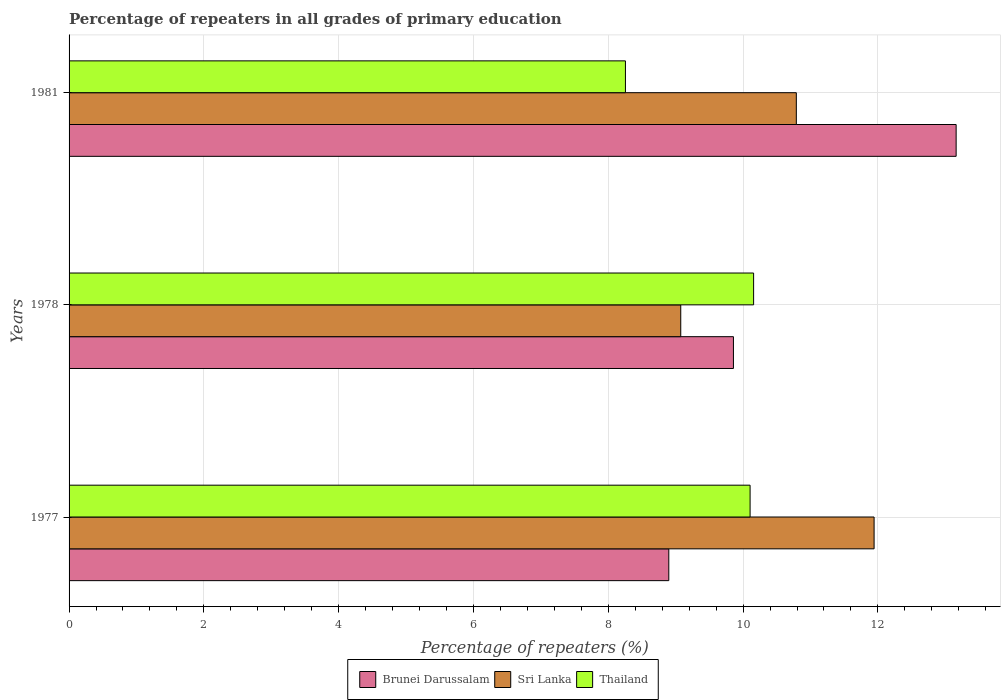How many groups of bars are there?
Offer a very short reply. 3. Are the number of bars on each tick of the Y-axis equal?
Give a very brief answer. Yes. How many bars are there on the 2nd tick from the bottom?
Ensure brevity in your answer.  3. What is the label of the 3rd group of bars from the top?
Ensure brevity in your answer.  1977. In how many cases, is the number of bars for a given year not equal to the number of legend labels?
Keep it short and to the point. 0. What is the percentage of repeaters in Sri Lanka in 1978?
Offer a very short reply. 9.08. Across all years, what is the maximum percentage of repeaters in Brunei Darussalam?
Make the answer very short. 13.16. Across all years, what is the minimum percentage of repeaters in Sri Lanka?
Your answer should be compact. 9.08. In which year was the percentage of repeaters in Brunei Darussalam maximum?
Provide a short and direct response. 1981. What is the total percentage of repeaters in Sri Lanka in the graph?
Ensure brevity in your answer.  31.81. What is the difference between the percentage of repeaters in Sri Lanka in 1977 and that in 1978?
Provide a short and direct response. 2.87. What is the difference between the percentage of repeaters in Sri Lanka in 1981 and the percentage of repeaters in Thailand in 1978?
Your response must be concise. 0.63. What is the average percentage of repeaters in Sri Lanka per year?
Make the answer very short. 10.6. In the year 1977, what is the difference between the percentage of repeaters in Thailand and percentage of repeaters in Sri Lanka?
Make the answer very short. -1.84. In how many years, is the percentage of repeaters in Sri Lanka greater than 10.8 %?
Your answer should be very brief. 1. What is the ratio of the percentage of repeaters in Sri Lanka in 1977 to that in 1978?
Your answer should be very brief. 1.32. Is the difference between the percentage of repeaters in Thailand in 1977 and 1978 greater than the difference between the percentage of repeaters in Sri Lanka in 1977 and 1978?
Provide a succinct answer. No. What is the difference between the highest and the second highest percentage of repeaters in Thailand?
Ensure brevity in your answer.  0.05. What is the difference between the highest and the lowest percentage of repeaters in Sri Lanka?
Offer a terse response. 2.87. In how many years, is the percentage of repeaters in Brunei Darussalam greater than the average percentage of repeaters in Brunei Darussalam taken over all years?
Your answer should be compact. 1. What does the 3rd bar from the top in 1981 represents?
Keep it short and to the point. Brunei Darussalam. What does the 3rd bar from the bottom in 1978 represents?
Offer a terse response. Thailand. Are all the bars in the graph horizontal?
Offer a very short reply. Yes. Does the graph contain any zero values?
Keep it short and to the point. No. Where does the legend appear in the graph?
Offer a very short reply. Bottom center. How many legend labels are there?
Ensure brevity in your answer.  3. What is the title of the graph?
Your answer should be very brief. Percentage of repeaters in all grades of primary education. What is the label or title of the X-axis?
Keep it short and to the point. Percentage of repeaters (%). What is the Percentage of repeaters (%) in Brunei Darussalam in 1977?
Your answer should be compact. 8.9. What is the Percentage of repeaters (%) of Sri Lanka in 1977?
Your response must be concise. 11.94. What is the Percentage of repeaters (%) of Thailand in 1977?
Your response must be concise. 10.1. What is the Percentage of repeaters (%) of Brunei Darussalam in 1978?
Your answer should be compact. 9.86. What is the Percentage of repeaters (%) of Sri Lanka in 1978?
Keep it short and to the point. 9.08. What is the Percentage of repeaters (%) of Thailand in 1978?
Offer a very short reply. 10.16. What is the Percentage of repeaters (%) in Brunei Darussalam in 1981?
Give a very brief answer. 13.16. What is the Percentage of repeaters (%) in Sri Lanka in 1981?
Give a very brief answer. 10.79. What is the Percentage of repeaters (%) of Thailand in 1981?
Offer a terse response. 8.25. Across all years, what is the maximum Percentage of repeaters (%) of Brunei Darussalam?
Your response must be concise. 13.16. Across all years, what is the maximum Percentage of repeaters (%) in Sri Lanka?
Provide a succinct answer. 11.94. Across all years, what is the maximum Percentage of repeaters (%) in Thailand?
Provide a succinct answer. 10.16. Across all years, what is the minimum Percentage of repeaters (%) of Brunei Darussalam?
Your answer should be compact. 8.9. Across all years, what is the minimum Percentage of repeaters (%) in Sri Lanka?
Offer a terse response. 9.08. Across all years, what is the minimum Percentage of repeaters (%) of Thailand?
Keep it short and to the point. 8.25. What is the total Percentage of repeaters (%) in Brunei Darussalam in the graph?
Your response must be concise. 31.92. What is the total Percentage of repeaters (%) in Sri Lanka in the graph?
Offer a very short reply. 31.81. What is the total Percentage of repeaters (%) of Thailand in the graph?
Give a very brief answer. 28.51. What is the difference between the Percentage of repeaters (%) in Brunei Darussalam in 1977 and that in 1978?
Offer a terse response. -0.96. What is the difference between the Percentage of repeaters (%) of Sri Lanka in 1977 and that in 1978?
Keep it short and to the point. 2.87. What is the difference between the Percentage of repeaters (%) of Thailand in 1977 and that in 1978?
Offer a terse response. -0.05. What is the difference between the Percentage of repeaters (%) of Brunei Darussalam in 1977 and that in 1981?
Keep it short and to the point. -4.26. What is the difference between the Percentage of repeaters (%) in Sri Lanka in 1977 and that in 1981?
Give a very brief answer. 1.15. What is the difference between the Percentage of repeaters (%) in Thailand in 1977 and that in 1981?
Offer a very short reply. 1.85. What is the difference between the Percentage of repeaters (%) of Brunei Darussalam in 1978 and that in 1981?
Provide a succinct answer. -3.3. What is the difference between the Percentage of repeaters (%) of Sri Lanka in 1978 and that in 1981?
Make the answer very short. -1.71. What is the difference between the Percentage of repeaters (%) in Thailand in 1978 and that in 1981?
Offer a terse response. 1.9. What is the difference between the Percentage of repeaters (%) of Brunei Darussalam in 1977 and the Percentage of repeaters (%) of Sri Lanka in 1978?
Your answer should be very brief. -0.18. What is the difference between the Percentage of repeaters (%) of Brunei Darussalam in 1977 and the Percentage of repeaters (%) of Thailand in 1978?
Your response must be concise. -1.26. What is the difference between the Percentage of repeaters (%) of Sri Lanka in 1977 and the Percentage of repeaters (%) of Thailand in 1978?
Your response must be concise. 1.79. What is the difference between the Percentage of repeaters (%) in Brunei Darussalam in 1977 and the Percentage of repeaters (%) in Sri Lanka in 1981?
Give a very brief answer. -1.89. What is the difference between the Percentage of repeaters (%) of Brunei Darussalam in 1977 and the Percentage of repeaters (%) of Thailand in 1981?
Offer a very short reply. 0.64. What is the difference between the Percentage of repeaters (%) in Sri Lanka in 1977 and the Percentage of repeaters (%) in Thailand in 1981?
Offer a terse response. 3.69. What is the difference between the Percentage of repeaters (%) in Brunei Darussalam in 1978 and the Percentage of repeaters (%) in Sri Lanka in 1981?
Make the answer very short. -0.93. What is the difference between the Percentage of repeaters (%) in Brunei Darussalam in 1978 and the Percentage of repeaters (%) in Thailand in 1981?
Give a very brief answer. 1.6. What is the difference between the Percentage of repeaters (%) of Sri Lanka in 1978 and the Percentage of repeaters (%) of Thailand in 1981?
Provide a succinct answer. 0.82. What is the average Percentage of repeaters (%) of Brunei Darussalam per year?
Make the answer very short. 10.64. What is the average Percentage of repeaters (%) of Sri Lanka per year?
Your answer should be very brief. 10.6. What is the average Percentage of repeaters (%) in Thailand per year?
Offer a terse response. 9.5. In the year 1977, what is the difference between the Percentage of repeaters (%) in Brunei Darussalam and Percentage of repeaters (%) in Sri Lanka?
Provide a succinct answer. -3.05. In the year 1977, what is the difference between the Percentage of repeaters (%) in Brunei Darussalam and Percentage of repeaters (%) in Thailand?
Your response must be concise. -1.21. In the year 1977, what is the difference between the Percentage of repeaters (%) in Sri Lanka and Percentage of repeaters (%) in Thailand?
Your answer should be compact. 1.84. In the year 1978, what is the difference between the Percentage of repeaters (%) in Brunei Darussalam and Percentage of repeaters (%) in Sri Lanka?
Offer a terse response. 0.78. In the year 1978, what is the difference between the Percentage of repeaters (%) of Brunei Darussalam and Percentage of repeaters (%) of Thailand?
Give a very brief answer. -0.3. In the year 1978, what is the difference between the Percentage of repeaters (%) of Sri Lanka and Percentage of repeaters (%) of Thailand?
Provide a short and direct response. -1.08. In the year 1981, what is the difference between the Percentage of repeaters (%) in Brunei Darussalam and Percentage of repeaters (%) in Sri Lanka?
Your answer should be compact. 2.37. In the year 1981, what is the difference between the Percentage of repeaters (%) in Brunei Darussalam and Percentage of repeaters (%) in Thailand?
Your response must be concise. 4.91. In the year 1981, what is the difference between the Percentage of repeaters (%) in Sri Lanka and Percentage of repeaters (%) in Thailand?
Your answer should be very brief. 2.54. What is the ratio of the Percentage of repeaters (%) in Brunei Darussalam in 1977 to that in 1978?
Provide a short and direct response. 0.9. What is the ratio of the Percentage of repeaters (%) of Sri Lanka in 1977 to that in 1978?
Make the answer very short. 1.32. What is the ratio of the Percentage of repeaters (%) in Thailand in 1977 to that in 1978?
Your answer should be compact. 0.99. What is the ratio of the Percentage of repeaters (%) of Brunei Darussalam in 1977 to that in 1981?
Ensure brevity in your answer.  0.68. What is the ratio of the Percentage of repeaters (%) in Sri Lanka in 1977 to that in 1981?
Give a very brief answer. 1.11. What is the ratio of the Percentage of repeaters (%) of Thailand in 1977 to that in 1981?
Your response must be concise. 1.22. What is the ratio of the Percentage of repeaters (%) in Brunei Darussalam in 1978 to that in 1981?
Provide a succinct answer. 0.75. What is the ratio of the Percentage of repeaters (%) in Sri Lanka in 1978 to that in 1981?
Offer a terse response. 0.84. What is the ratio of the Percentage of repeaters (%) of Thailand in 1978 to that in 1981?
Provide a succinct answer. 1.23. What is the difference between the highest and the second highest Percentage of repeaters (%) in Brunei Darussalam?
Make the answer very short. 3.3. What is the difference between the highest and the second highest Percentage of repeaters (%) of Sri Lanka?
Your answer should be very brief. 1.15. What is the difference between the highest and the second highest Percentage of repeaters (%) in Thailand?
Provide a succinct answer. 0.05. What is the difference between the highest and the lowest Percentage of repeaters (%) in Brunei Darussalam?
Give a very brief answer. 4.26. What is the difference between the highest and the lowest Percentage of repeaters (%) of Sri Lanka?
Give a very brief answer. 2.87. What is the difference between the highest and the lowest Percentage of repeaters (%) in Thailand?
Offer a terse response. 1.9. 